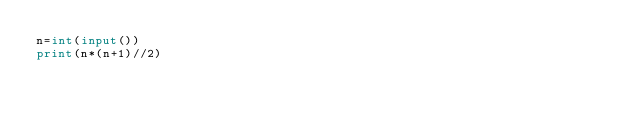<code> <loc_0><loc_0><loc_500><loc_500><_Python_>n=int(input())
print(n*(n+1)//2)</code> 